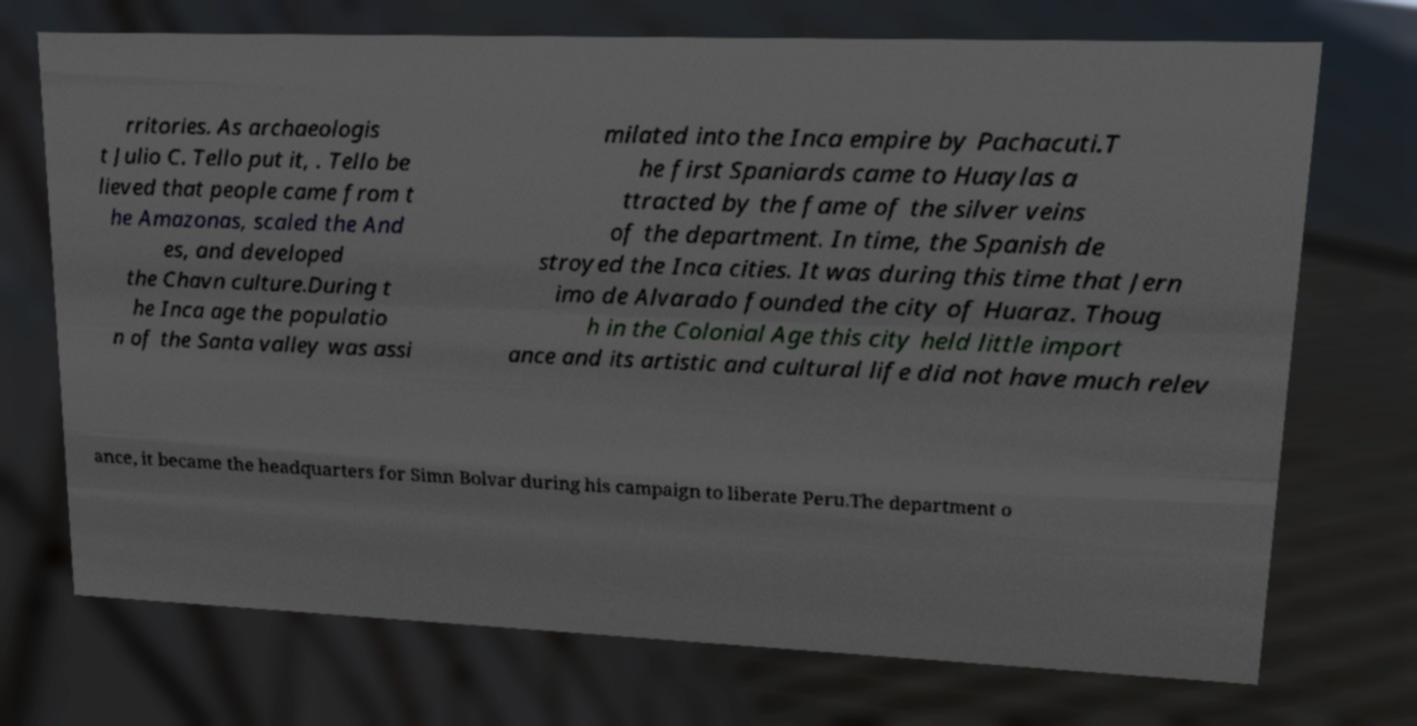I need the written content from this picture converted into text. Can you do that? rritories. As archaeologis t Julio C. Tello put it, . Tello be lieved that people came from t he Amazonas, scaled the And es, and developed the Chavn culture.During t he Inca age the populatio n of the Santa valley was assi milated into the Inca empire by Pachacuti.T he first Spaniards came to Huaylas a ttracted by the fame of the silver veins of the department. In time, the Spanish de stroyed the Inca cities. It was during this time that Jern imo de Alvarado founded the city of Huaraz. Thoug h in the Colonial Age this city held little import ance and its artistic and cultural life did not have much relev ance, it became the headquarters for Simn Bolvar during his campaign to liberate Peru.The department o 